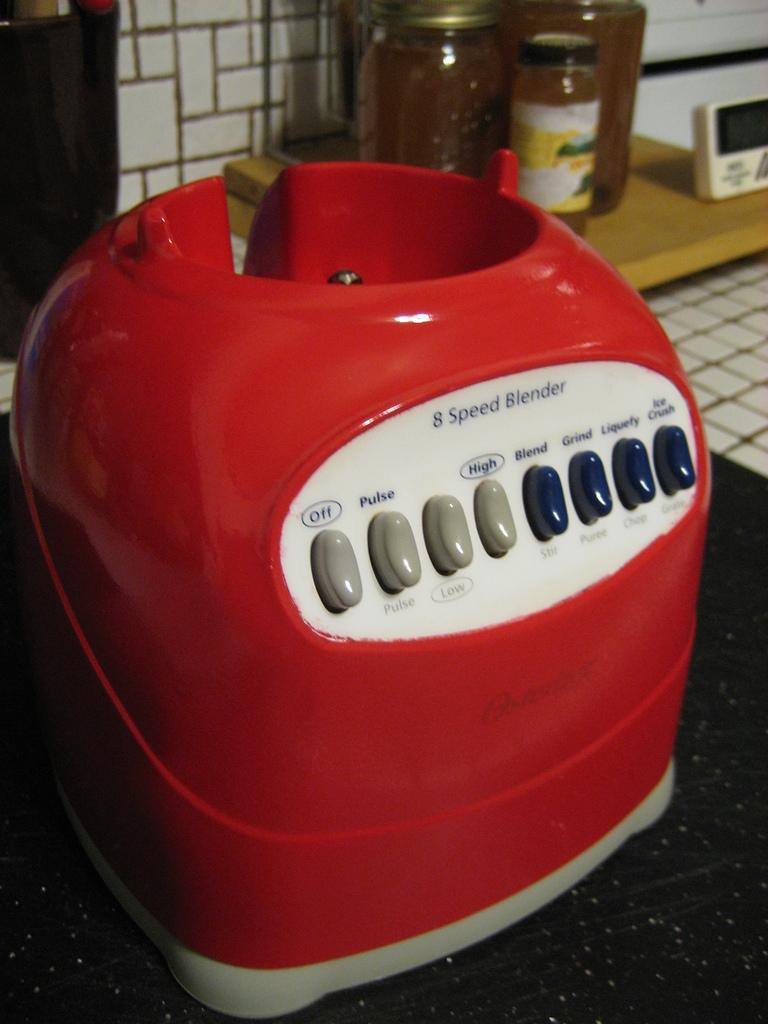<image>
Present a compact description of the photo's key features. a red blender that has the word pulse on it 